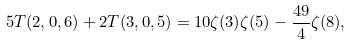Convert formula to latex. <formula><loc_0><loc_0><loc_500><loc_500>5 T ( 2 , 0 , 6 ) + 2 T ( 3 , 0 , 5 ) = 1 0 \zeta ( 3 ) \zeta ( 5 ) - \frac { 4 9 } { 4 } \zeta ( 8 ) ,</formula> 